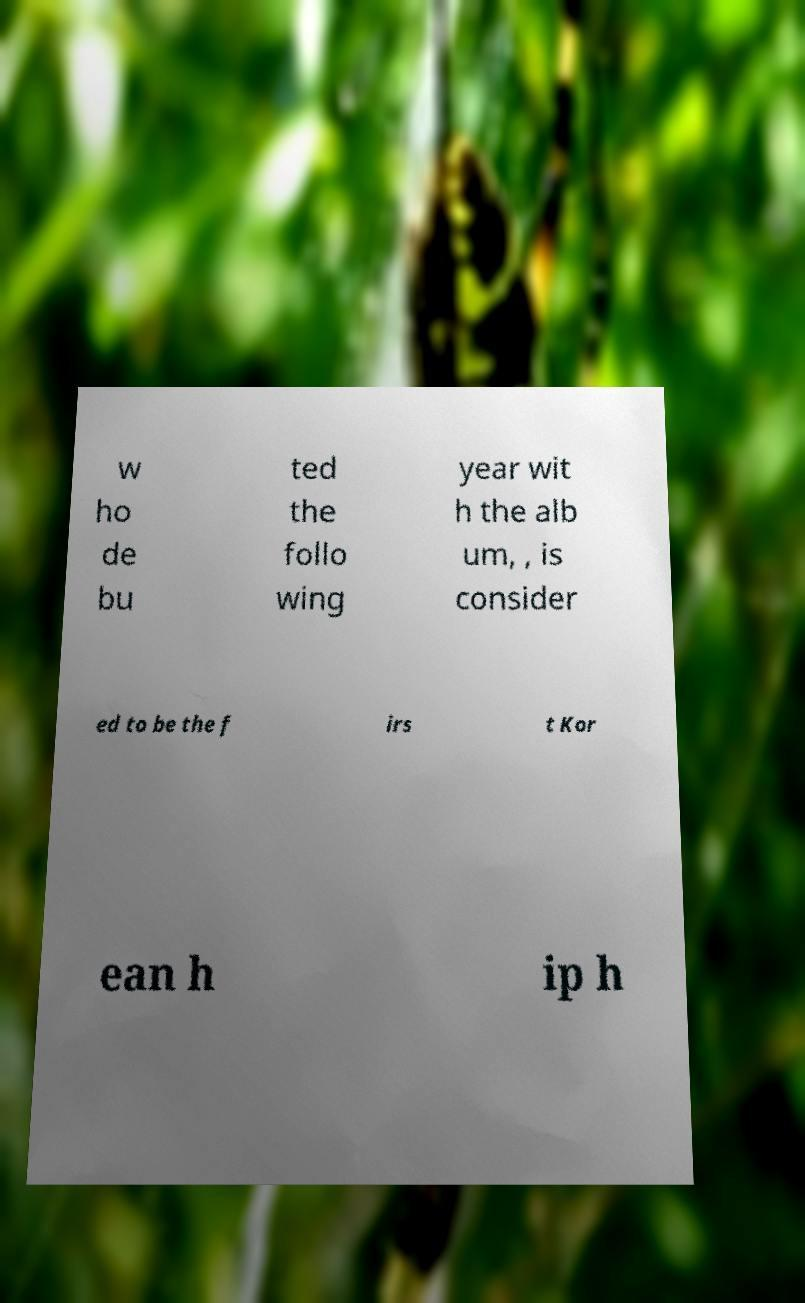Can you accurately transcribe the text from the provided image for me? w ho de bu ted the follo wing year wit h the alb um, , is consider ed to be the f irs t Kor ean h ip h 